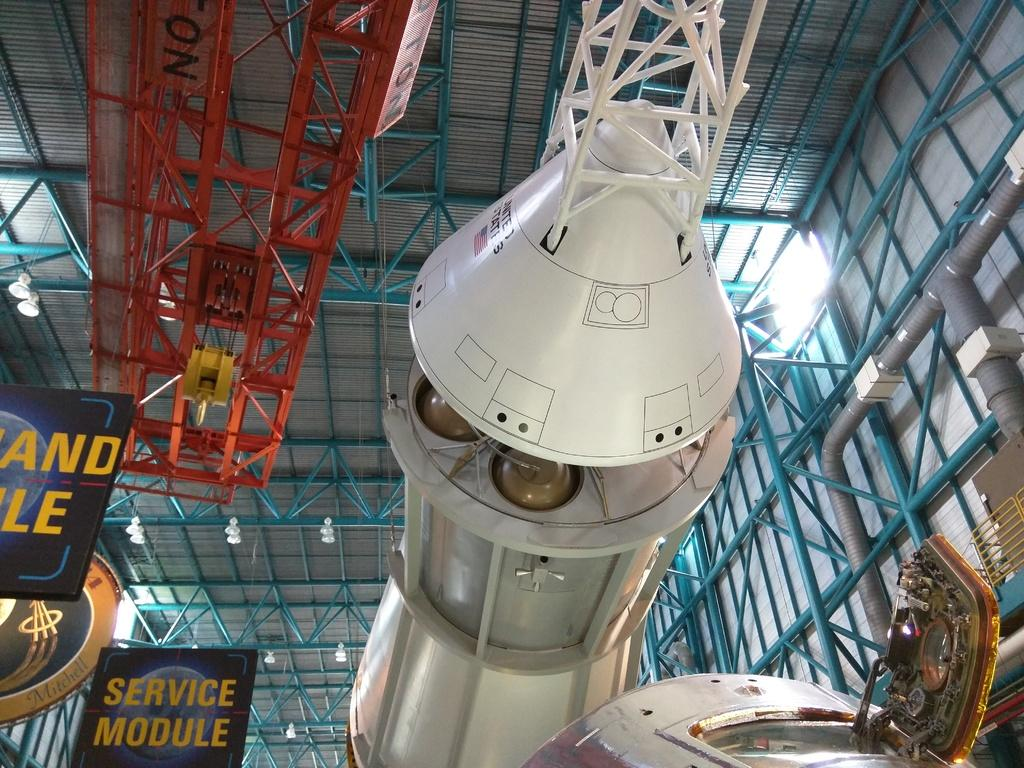Provide a one-sentence caption for the provided image. A looking up view at the service module of a spacecraft in a museums hangar. 